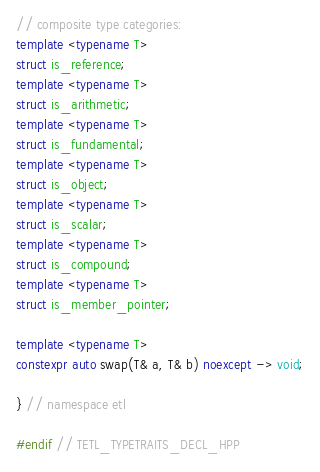<code> <loc_0><loc_0><loc_500><loc_500><_C++_>
// composite type categories:
template <typename T>
struct is_reference;
template <typename T>
struct is_arithmetic;
template <typename T>
struct is_fundamental;
template <typename T>
struct is_object;
template <typename T>
struct is_scalar;
template <typename T>
struct is_compound;
template <typename T>
struct is_member_pointer;

template <typename T>
constexpr auto swap(T& a, T& b) noexcept -> void;

} // namespace etl

#endif // TETL_TYPETRAITS_DECL_HPP</code> 